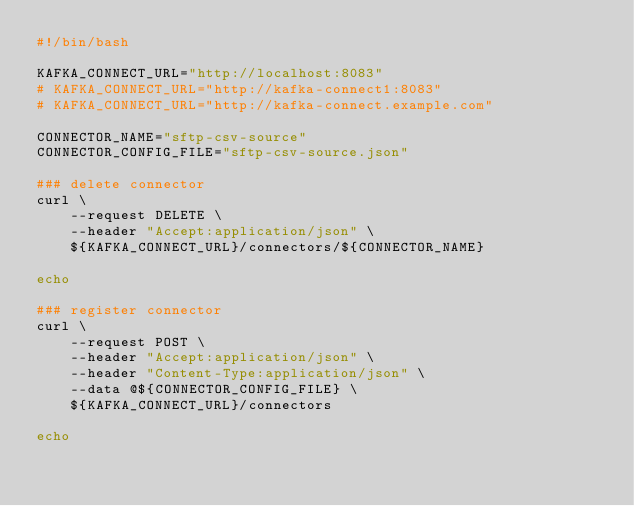Convert code to text. <code><loc_0><loc_0><loc_500><loc_500><_Bash_>#!/bin/bash

KAFKA_CONNECT_URL="http://localhost:8083"
# KAFKA_CONNECT_URL="http://kafka-connect1:8083"
# KAFKA_CONNECT_URL="http://kafka-connect.example.com"

CONNECTOR_NAME="sftp-csv-source"
CONNECTOR_CONFIG_FILE="sftp-csv-source.json"

### delete connector
curl \
    --request DELETE \
    --header "Accept:application/json" \
    ${KAFKA_CONNECT_URL}/connectors/${CONNECTOR_NAME}

echo

### register connector
curl \
    --request POST \
    --header "Accept:application/json" \
    --header "Content-Type:application/json" \
    --data @${CONNECTOR_CONFIG_FILE} \
    ${KAFKA_CONNECT_URL}/connectors

echo
</code> 